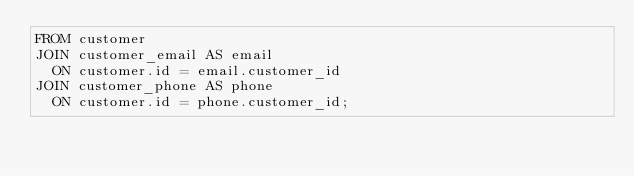<code> <loc_0><loc_0><loc_500><loc_500><_SQL_>FROM customer
JOIN customer_email AS email
  ON customer.id = email.customer_id
JOIN customer_phone AS phone
  ON customer.id = phone.customer_id;
</code> 